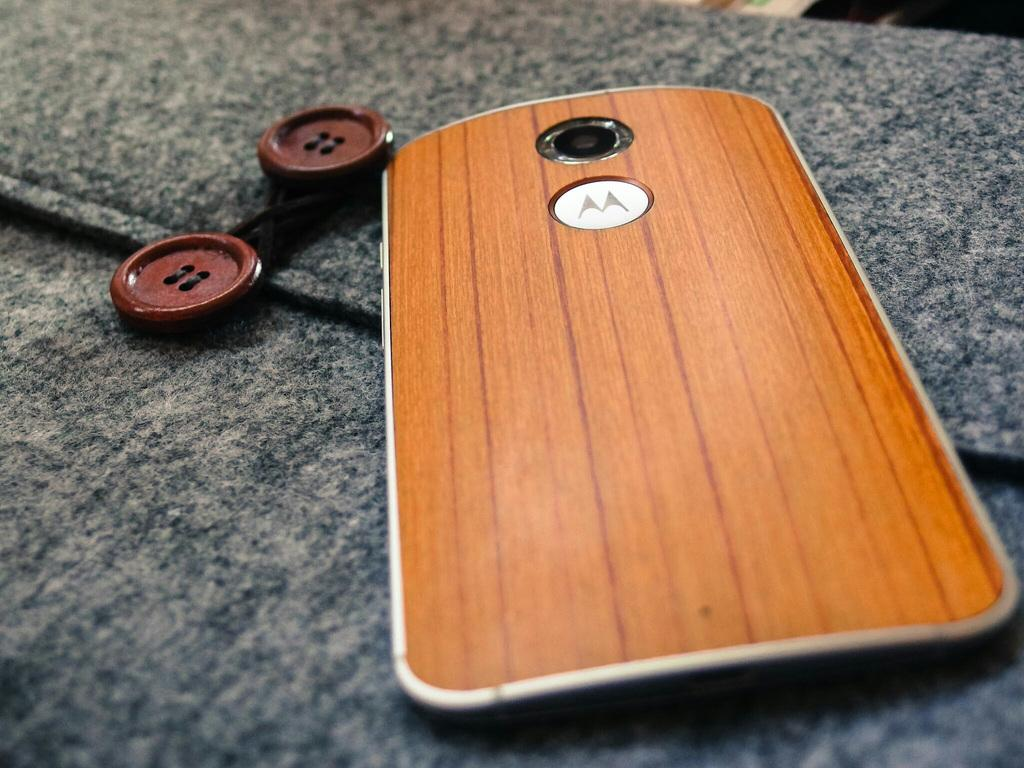Provide a one-sentence caption for the provided image. a phone with the motorola 'm' logo with a wood case. 